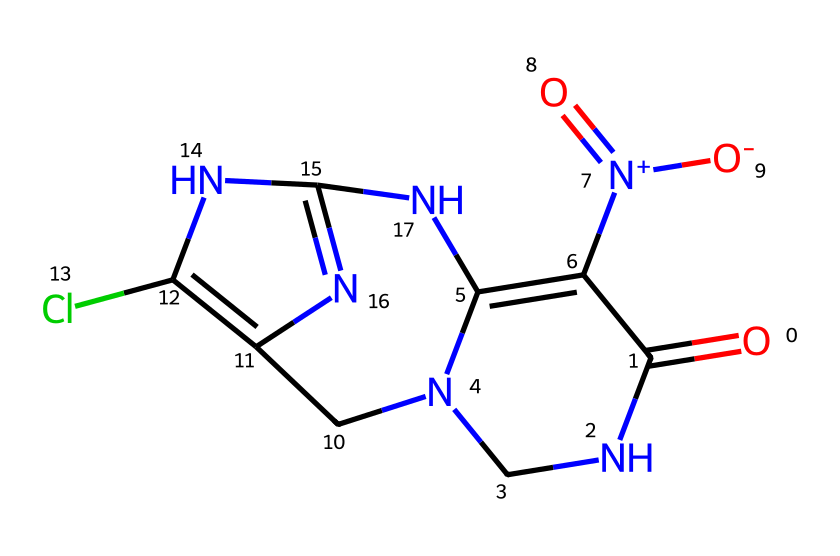What is the primary functional group in this molecule? The molecule features a carbonyl group (C=O) identified by the presence of a carbon atom double-bonded to an oxygen atom. Additionally, the surrounding structure indicates it is part of a ring system characteristic of heterocycles.
Answer: carbonyl group How many nitrogen atoms are present in this structure? By examining the SMILES representation and counting, there are three nitrogen atoms indicated, which correspond to the nitrogen locations in the ring and chains.
Answer: three What is the total number of rings in this compound? The SMILES shows two distinct cyclic structures, one being a 5-membered ring and another that is part of a larger fused ring system, confirming the presence of two rings in total.
Answer: two Does this molecule contain a chloride atom? The representation explicitly shows a chlorine atom (Cl) connected to a ring, indicating the presence of this halogen within the chemical structure.
Answer: yes What type of pesticide does this compound belong to? The structure fits the classification of neonicotinoids, characterized by its specific nitrogen arrangements and its action mechanism against insect pests, primarily through the modulation of nicotinic acetylcholine receptors.
Answer: neonicotinoids 